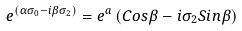<formula> <loc_0><loc_0><loc_500><loc_500>e ^ { \left ( \alpha \sigma _ { 0 } - i \beta \sigma _ { 2 } \right ) } = e ^ { a } \left ( C o s \beta - i \sigma _ { 2 } S i n \beta \right )</formula> 